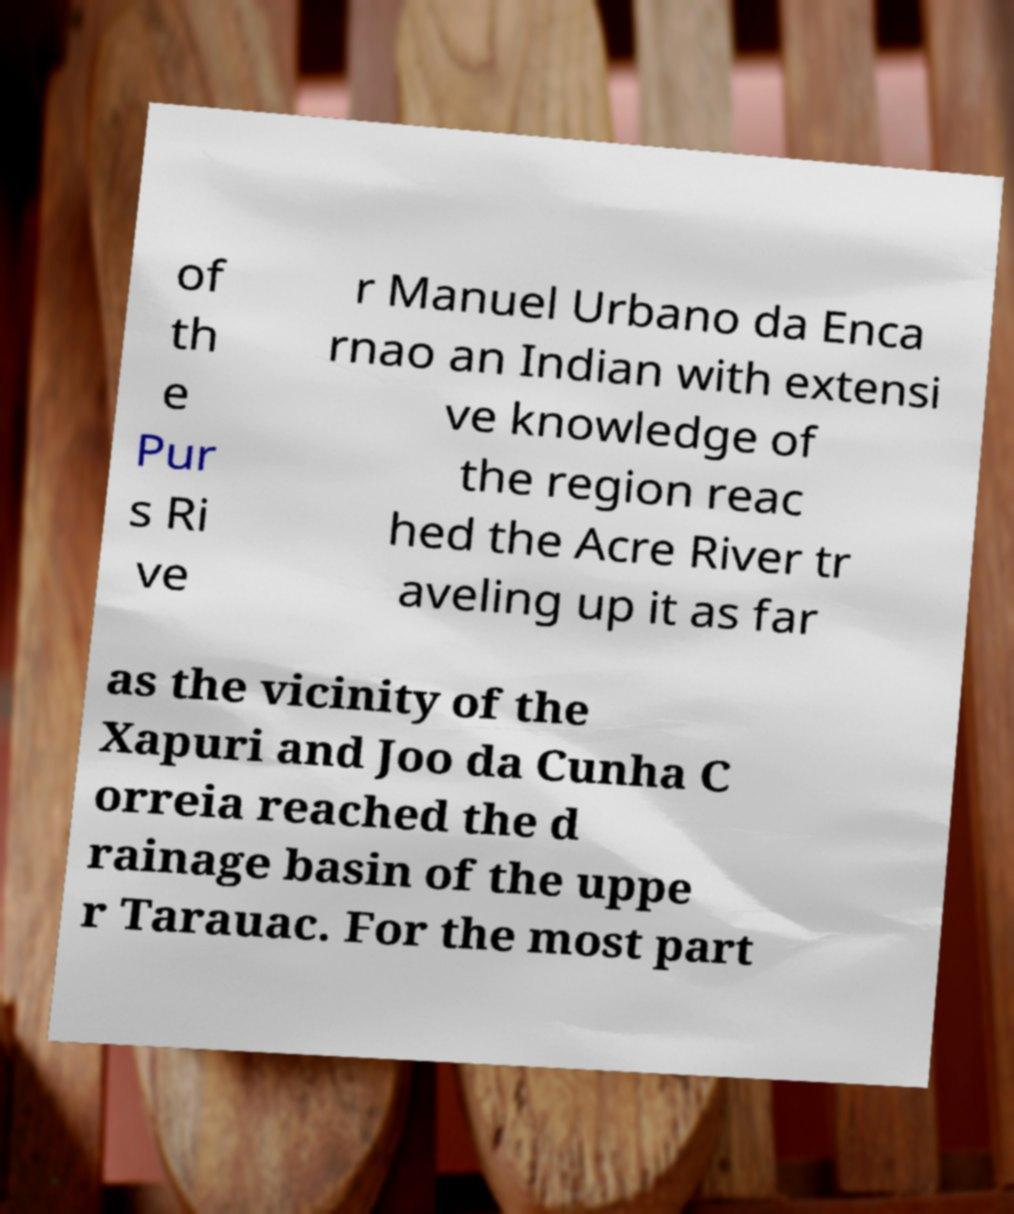Could you assist in decoding the text presented in this image and type it out clearly? of th e Pur s Ri ve r Manuel Urbano da Enca rnao an Indian with extensi ve knowledge of the region reac hed the Acre River tr aveling up it as far as the vicinity of the Xapuri and Joo da Cunha C orreia reached the d rainage basin of the uppe r Tarauac. For the most part 